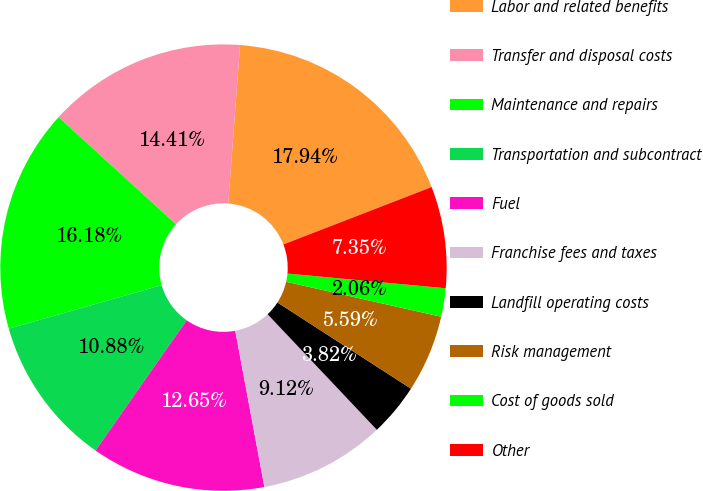Convert chart to OTSL. <chart><loc_0><loc_0><loc_500><loc_500><pie_chart><fcel>Labor and related benefits<fcel>Transfer and disposal costs<fcel>Maintenance and repairs<fcel>Transportation and subcontract<fcel>Fuel<fcel>Franchise fees and taxes<fcel>Landfill operating costs<fcel>Risk management<fcel>Cost of goods sold<fcel>Other<nl><fcel>17.94%<fcel>14.41%<fcel>16.18%<fcel>10.88%<fcel>12.65%<fcel>9.12%<fcel>3.82%<fcel>5.59%<fcel>2.06%<fcel>7.35%<nl></chart> 